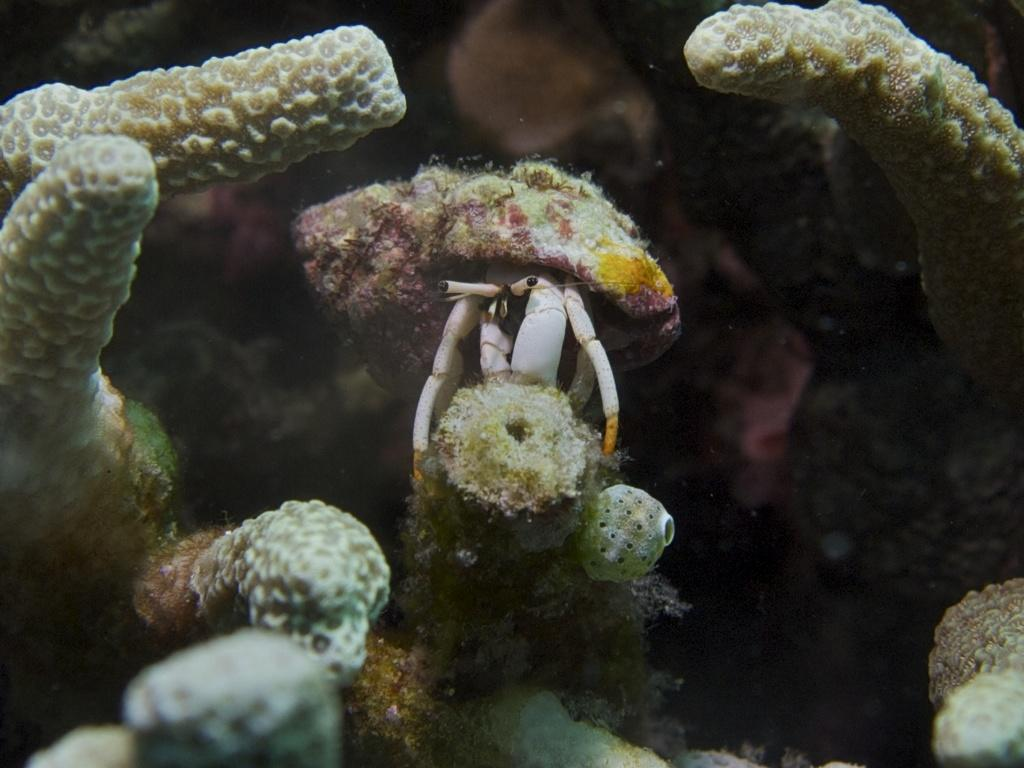What type of animal can be seen in the image? There is a sea creature in the image. Where is the sea creature located? The sea creature is on the seabed. What else can be found on the seabed in the image? There are objects on the seabed in the image. What idea does the rock have about the lift in the image? There is no rock or lift present in the image; it features a sea creature on the seabed with other objects. 